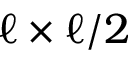<formula> <loc_0><loc_0><loc_500><loc_500>\ell \times \ell / 2</formula> 